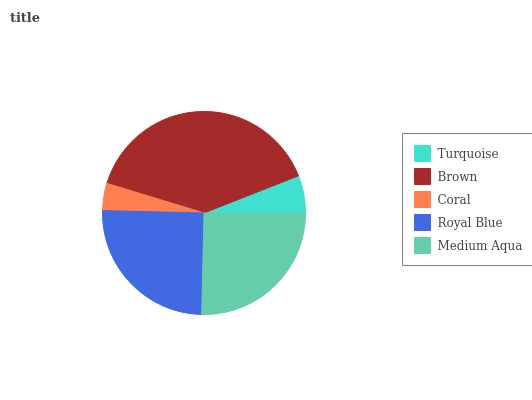Is Coral the minimum?
Answer yes or no. Yes. Is Brown the maximum?
Answer yes or no. Yes. Is Brown the minimum?
Answer yes or no. No. Is Coral the maximum?
Answer yes or no. No. Is Brown greater than Coral?
Answer yes or no. Yes. Is Coral less than Brown?
Answer yes or no. Yes. Is Coral greater than Brown?
Answer yes or no. No. Is Brown less than Coral?
Answer yes or no. No. Is Royal Blue the high median?
Answer yes or no. Yes. Is Royal Blue the low median?
Answer yes or no. Yes. Is Coral the high median?
Answer yes or no. No. Is Turquoise the low median?
Answer yes or no. No. 